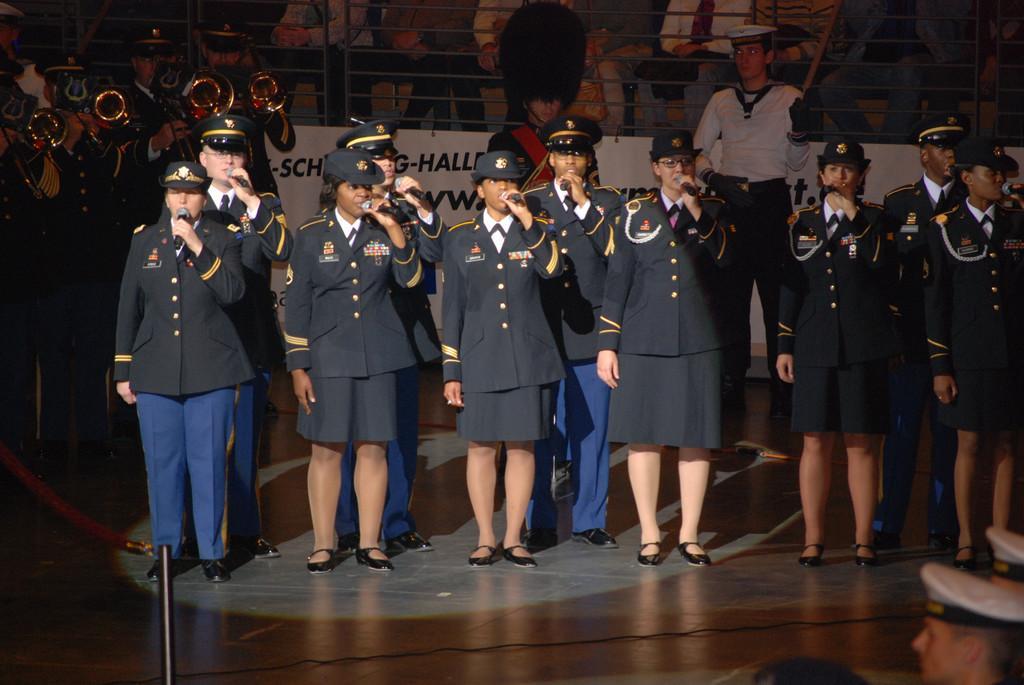Could you give a brief overview of what you see in this image? In the image I can see some people who are wearing the caps and holding the mics and to the side there are some other people who are playing musical instruments and also I can see a banner and some other people. 